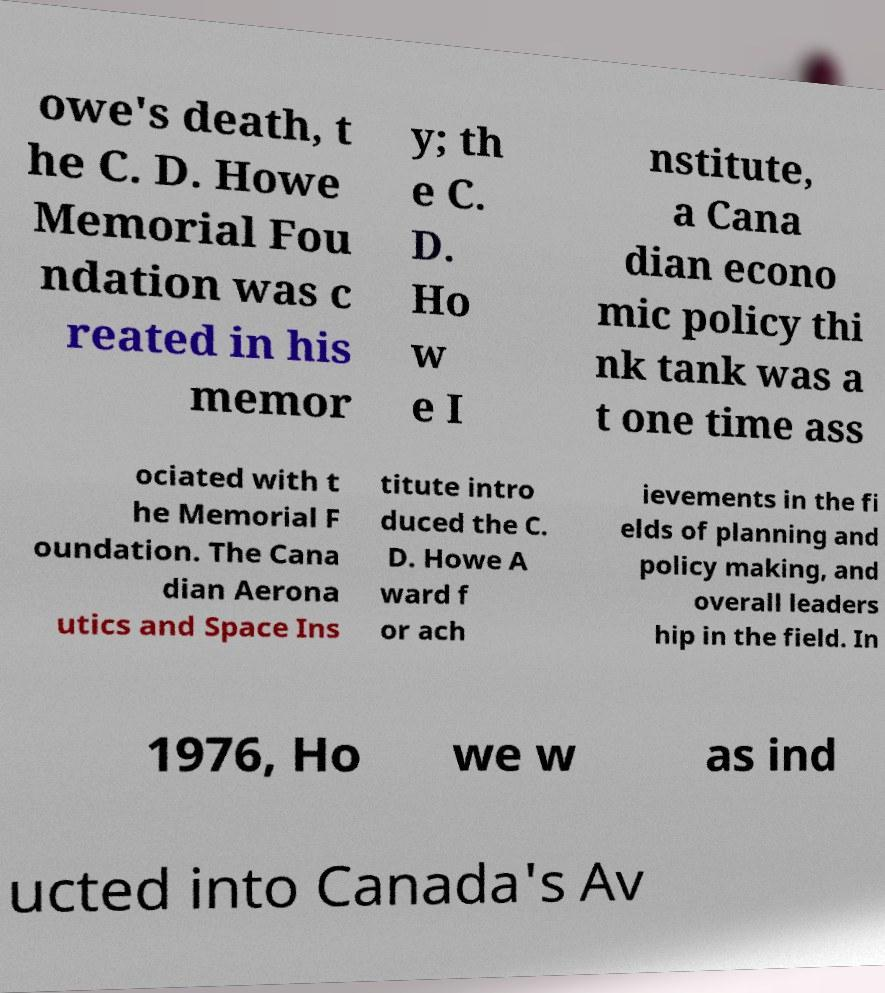Could you extract and type out the text from this image? owe's death, t he C. D. Howe Memorial Fou ndation was c reated in his memor y; th e C. D. Ho w e I nstitute, a Cana dian econo mic policy thi nk tank was a t one time ass ociated with t he Memorial F oundation. The Cana dian Aerona utics and Space Ins titute intro duced the C. D. Howe A ward f or ach ievements in the fi elds of planning and policy making, and overall leaders hip in the field. In 1976, Ho we w as ind ucted into Canada's Av 